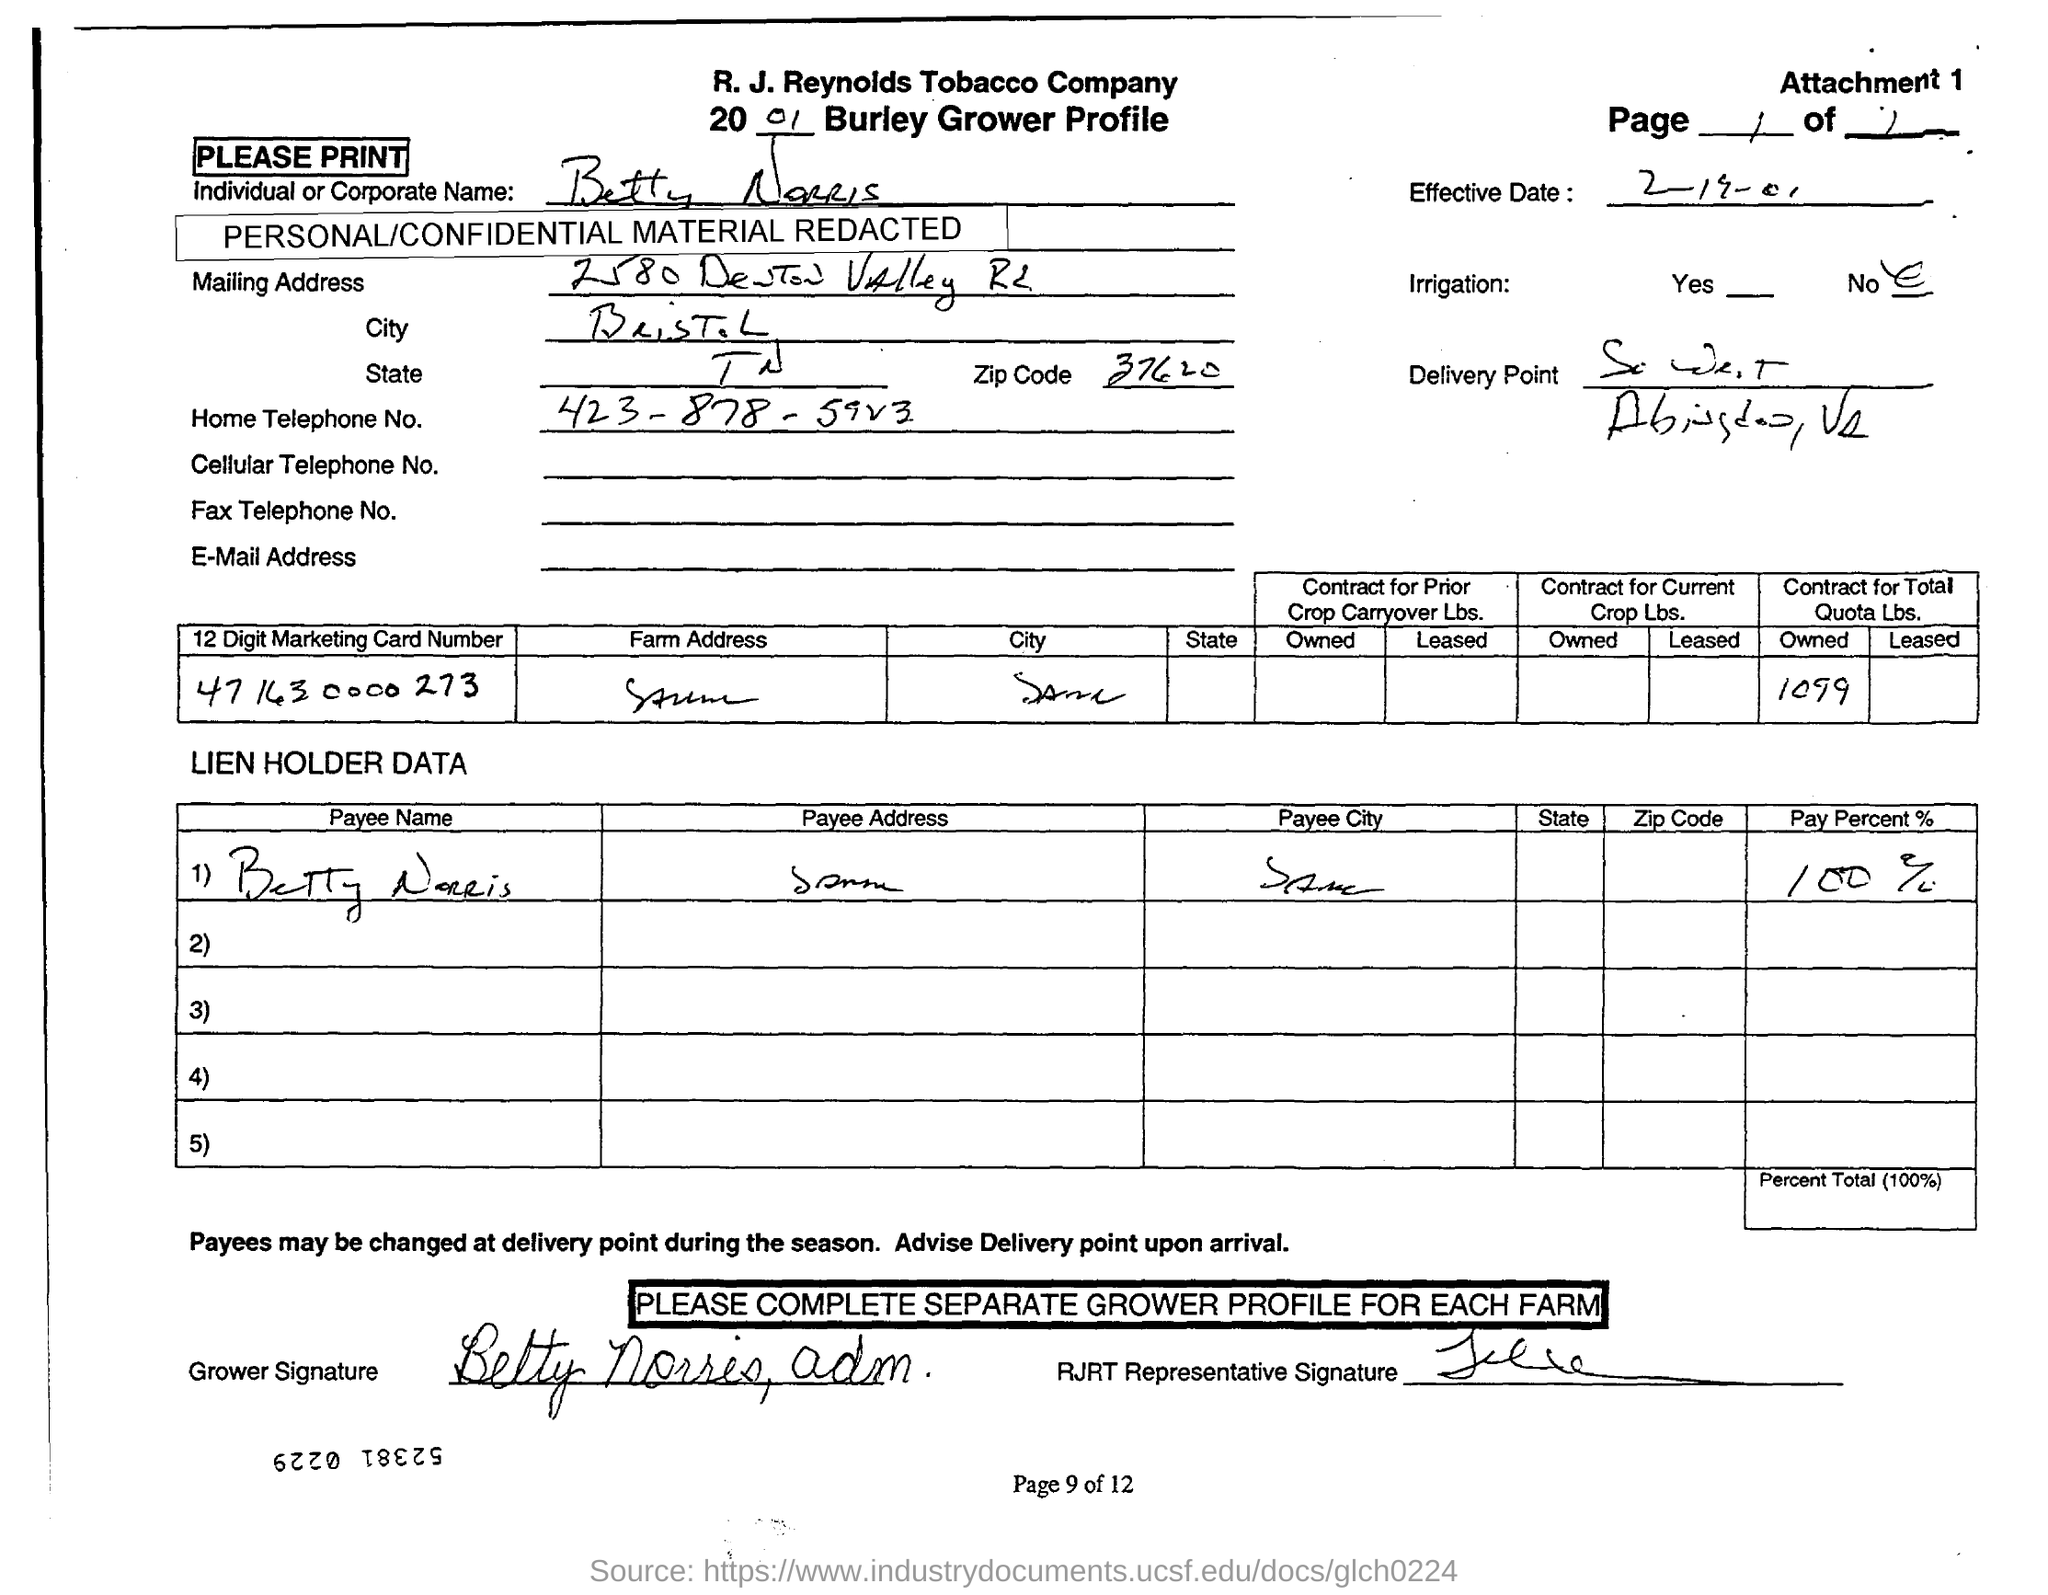Draw attention to some important aspects in this diagram. The payee's name listed in the document is "Betty Norris. The number provided in the document is 4716300000273. The grower profile of R. J. Reynolds Tobacco Company is provided. The effective date mentioned in the document is February 19, 2001. I, being a person with access to a telephone, know the home telephone number of Betty Norris to be 423-878-5923. 